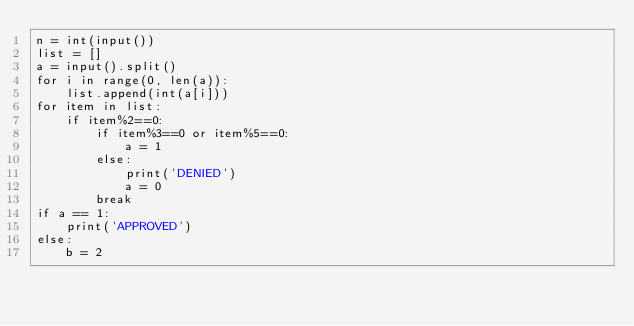<code> <loc_0><loc_0><loc_500><loc_500><_Python_>n = int(input())
list = []
a = input().split()
for i in range(0, len(a)):
    list.append(int(a[i]))
for item in list:
    if item%2==0:
        if item%3==0 or item%5==0:
            a = 1
        else:
            print('DENIED')
            a = 0
        break
if a == 1:
    print('APPROVED')
else:
    b = 2</code> 